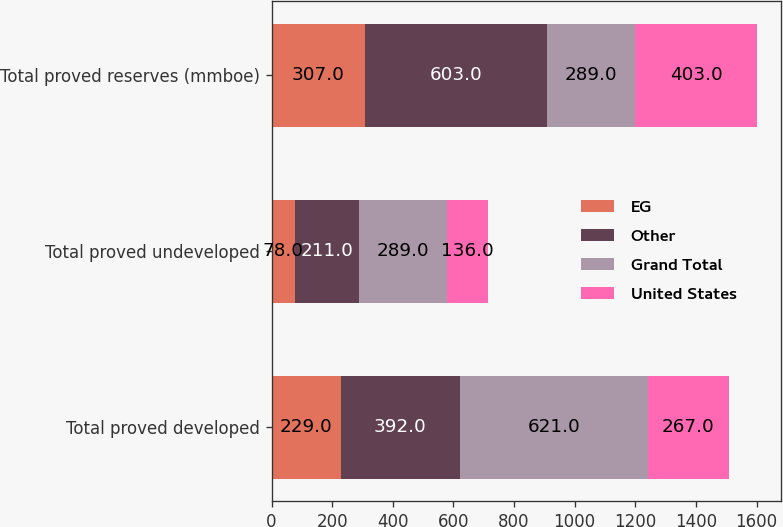Convert chart. <chart><loc_0><loc_0><loc_500><loc_500><stacked_bar_chart><ecel><fcel>Total proved developed<fcel>Total proved undeveloped<fcel>Total proved reserves (mmboe)<nl><fcel>EG<fcel>229<fcel>78<fcel>307<nl><fcel>Other<fcel>392<fcel>211<fcel>603<nl><fcel>Grand Total<fcel>621<fcel>289<fcel>289<nl><fcel>United States<fcel>267<fcel>136<fcel>403<nl></chart> 